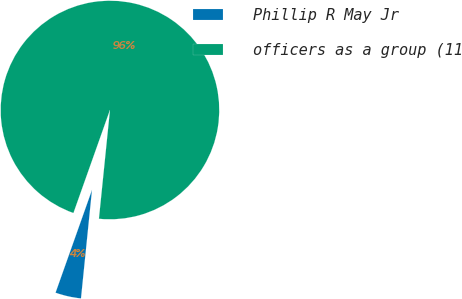<chart> <loc_0><loc_0><loc_500><loc_500><pie_chart><fcel>Phillip R May Jr<fcel>officers as a group (11<nl><fcel>3.81%<fcel>96.19%<nl></chart> 